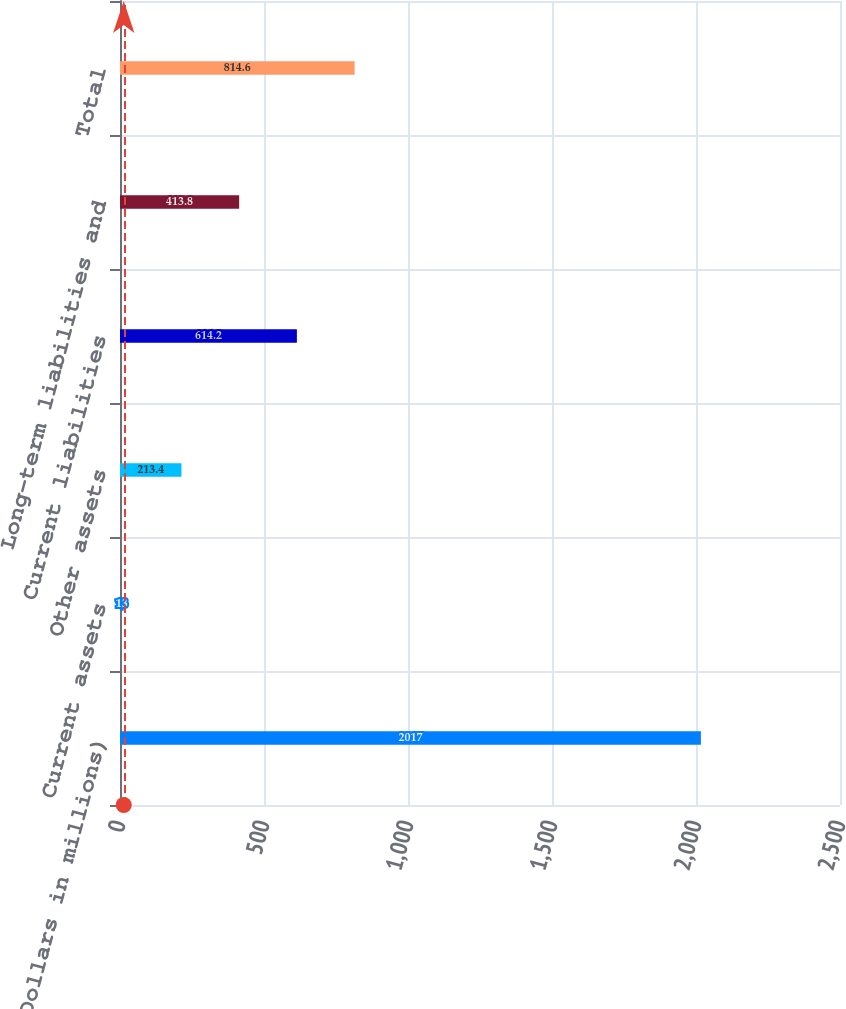<chart> <loc_0><loc_0><loc_500><loc_500><bar_chart><fcel>(Dollars in millions)<fcel>Current assets<fcel>Other assets<fcel>Current liabilities<fcel>Long-term liabilities and<fcel>Total<nl><fcel>2017<fcel>13<fcel>213.4<fcel>614.2<fcel>413.8<fcel>814.6<nl></chart> 